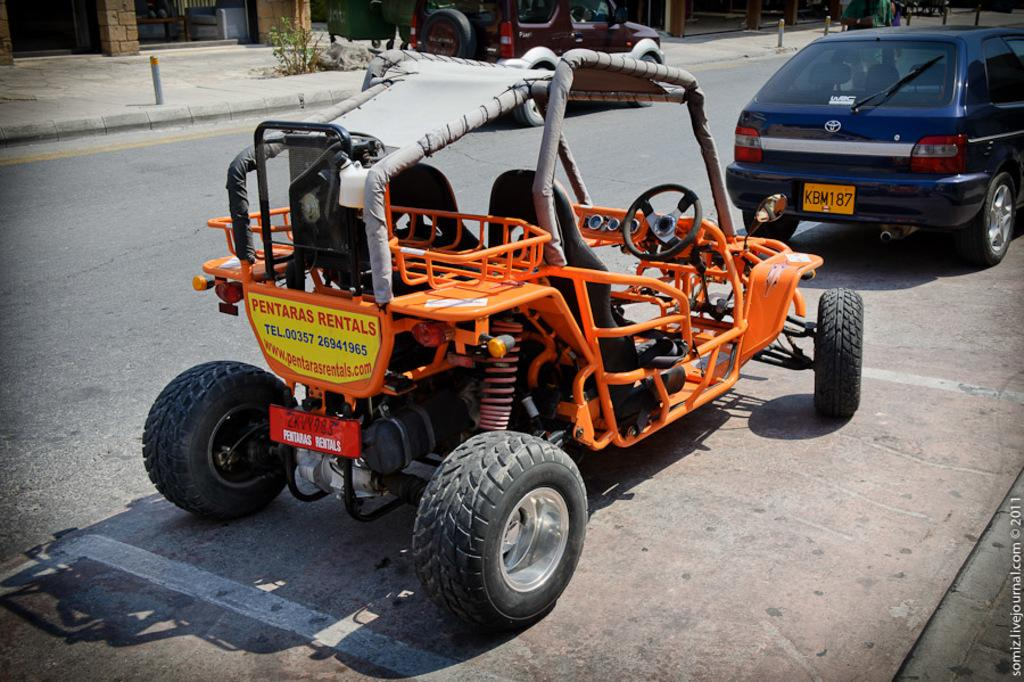What can be seen on the road in the image? There are vehicles on the road in the image. Can you describe one of the vehicles in the image? One of the vehicles is orange in color. What is visible in the background of the image? There are plants and poles in the background of the image, as well as other objects on the ground. How many friends are sitting on the edge of the orange vehicle in the image? There are no friends or edges of vehicles visible in the image. 